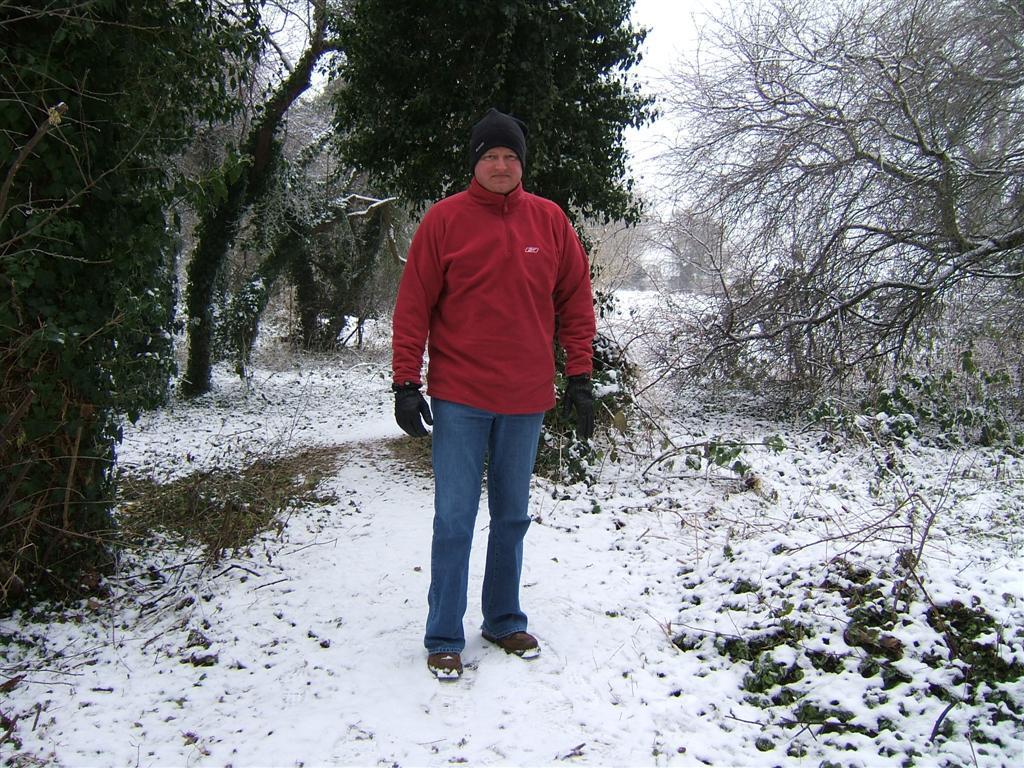How would you summarize this image in a sentence or two? In this image I can see a person standing and wearing red and blue color and black cap. Back I can see few trees and snow. 